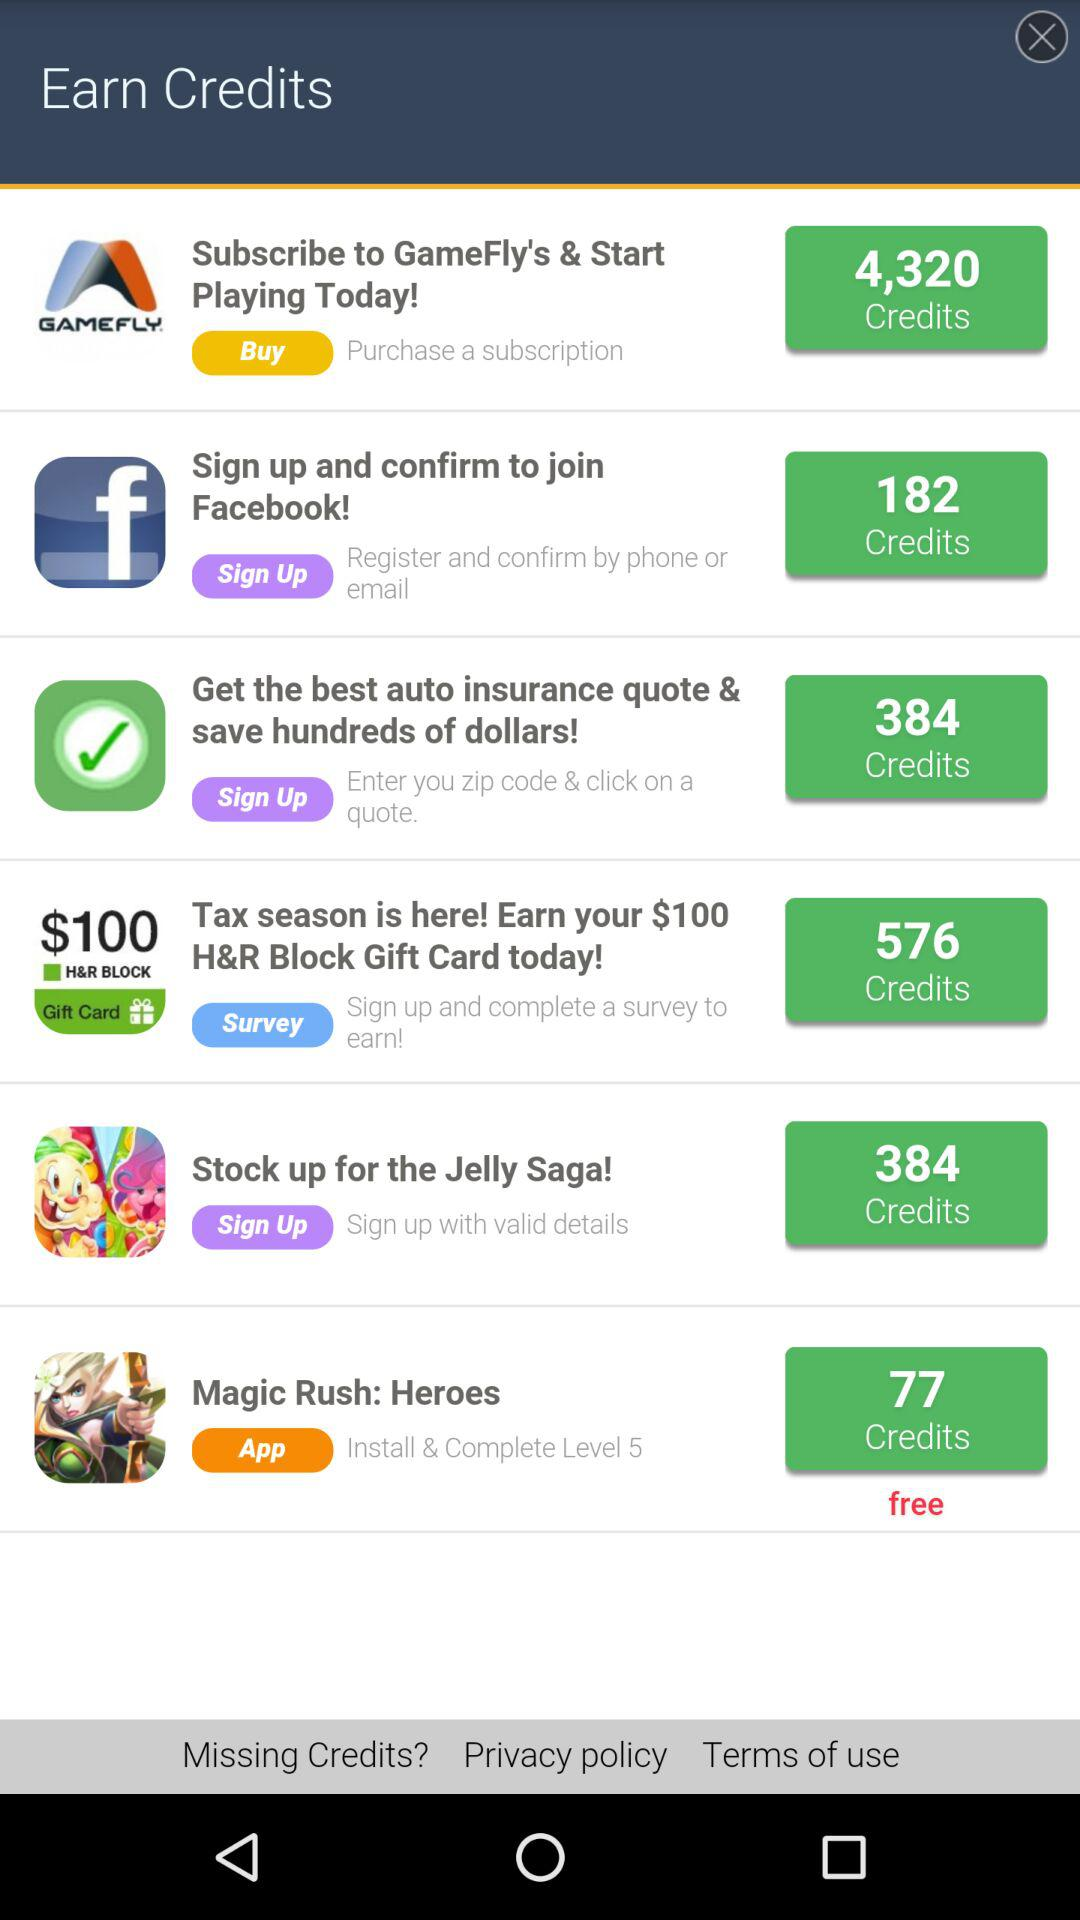What application is free? The application is "Magic Rush: Heroes". 